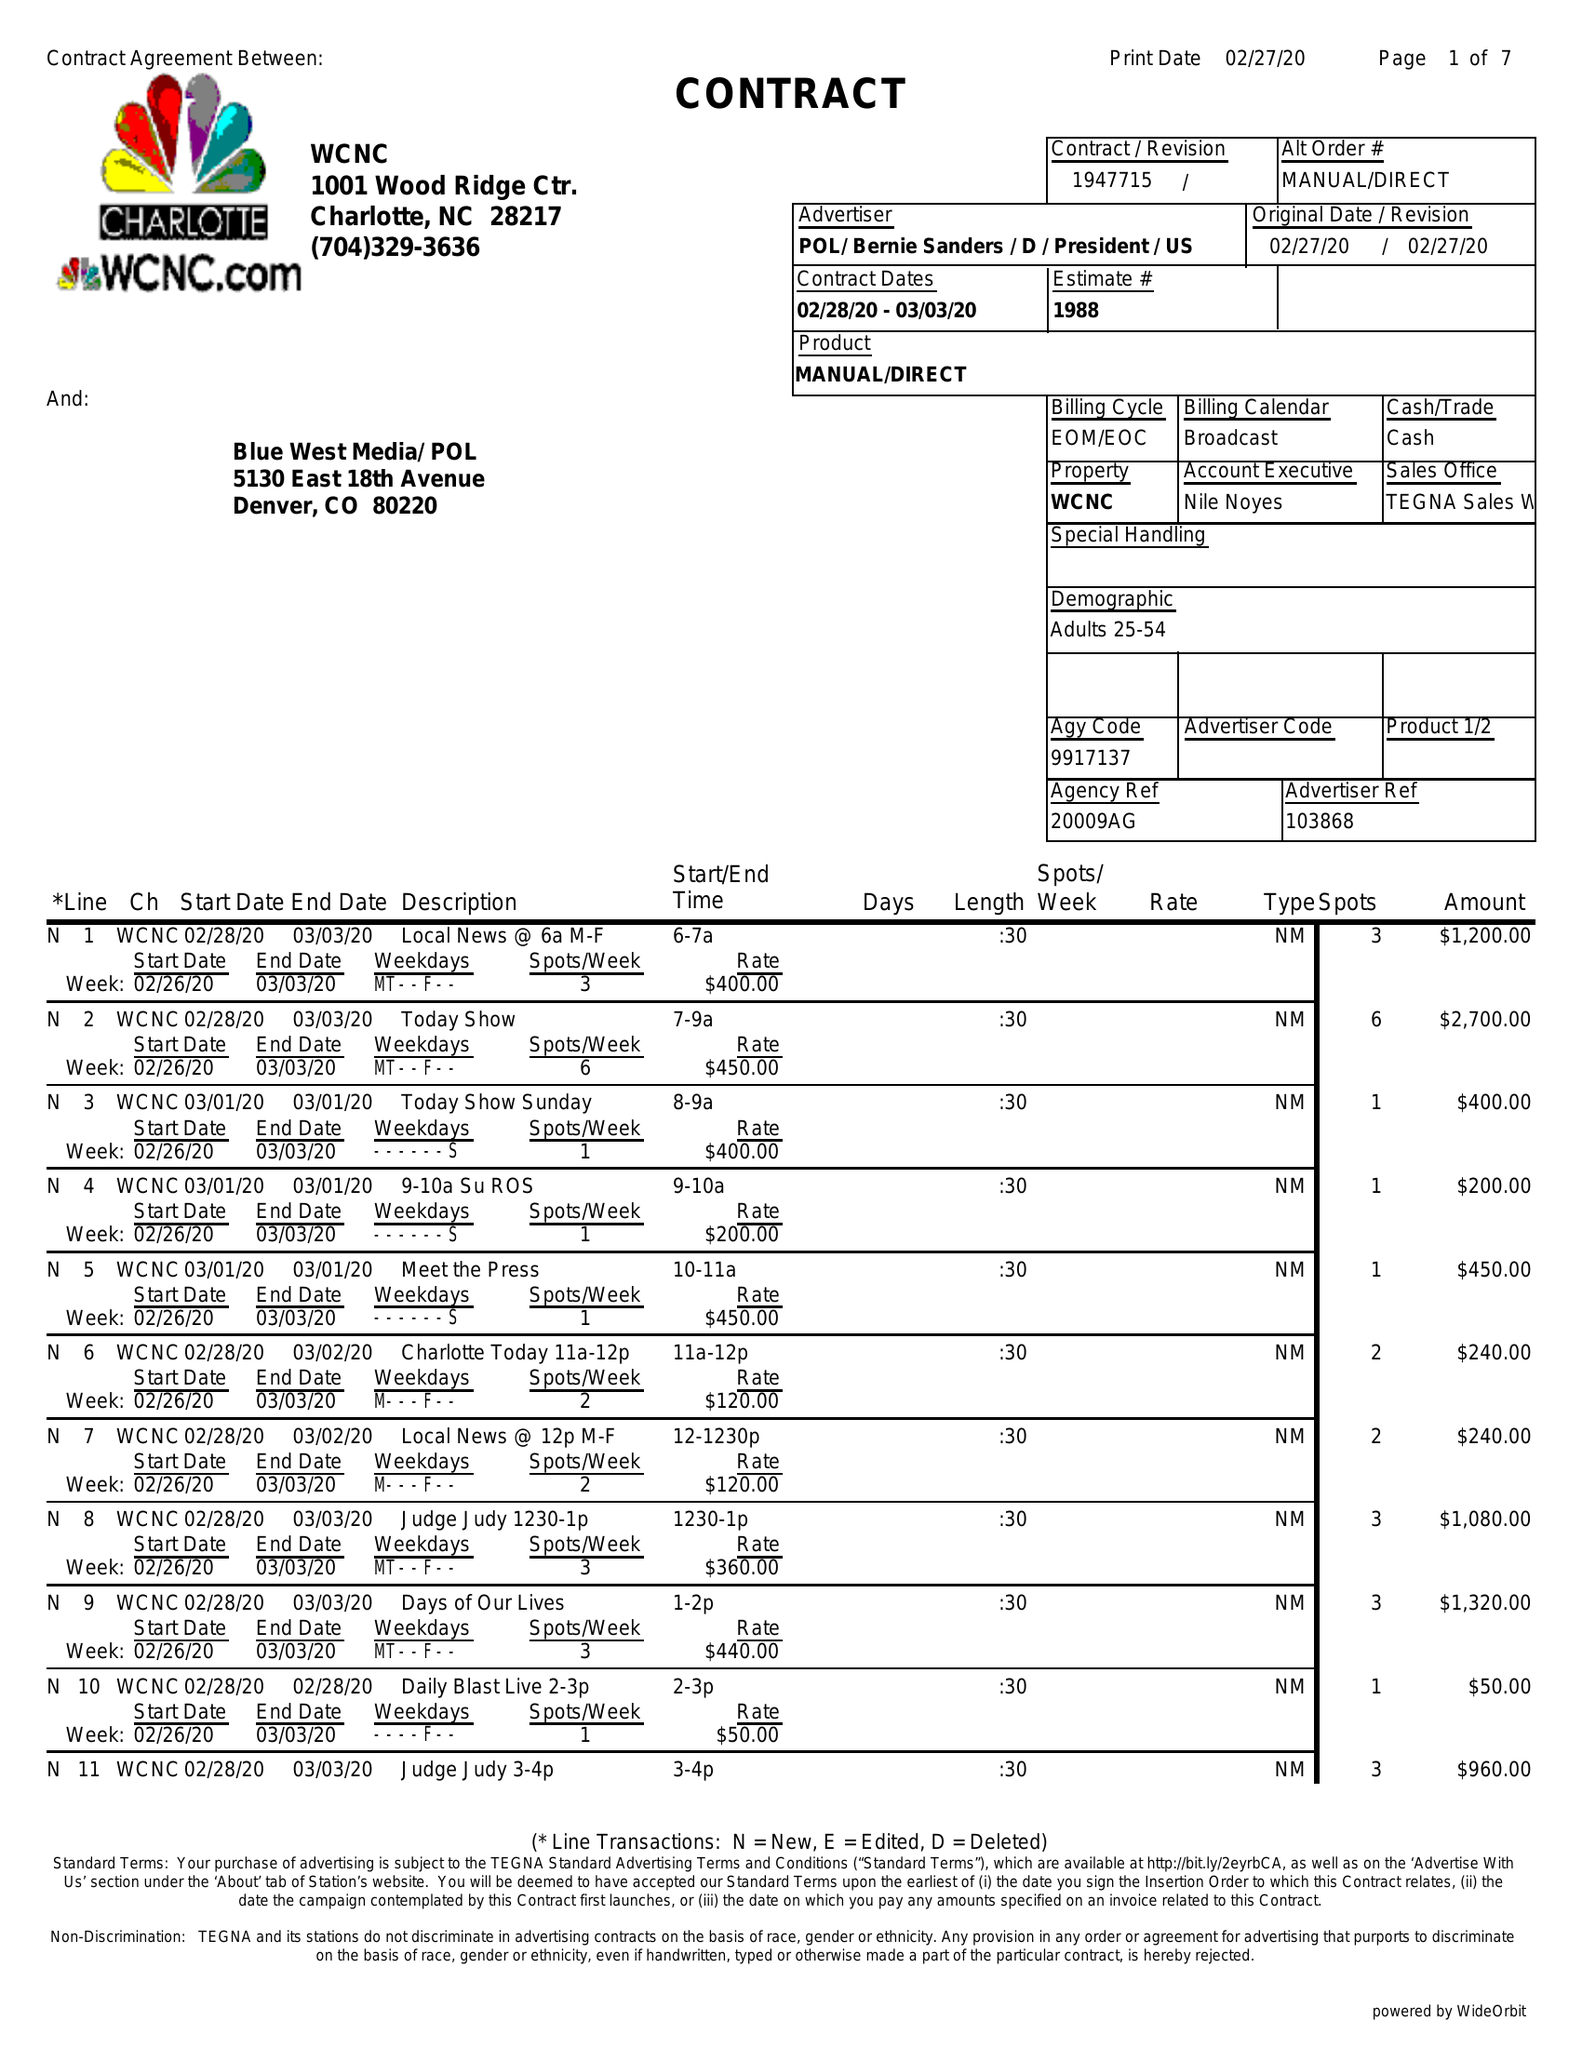What is the value for the flight_to?
Answer the question using a single word or phrase. 03/03/20 